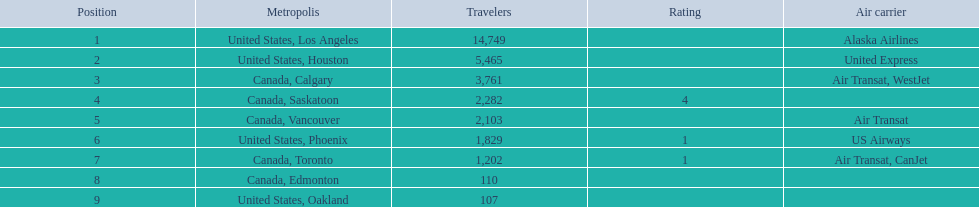How many cities on this list belong to canada? 5. 